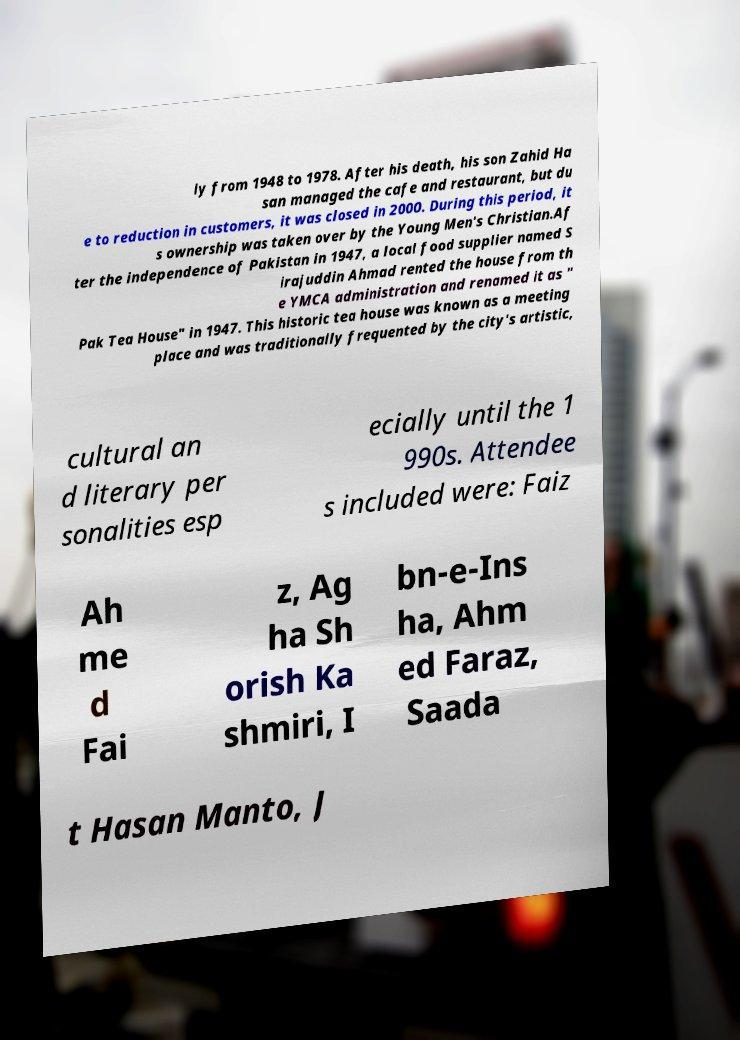Please identify and transcribe the text found in this image. ly from 1948 to 1978. After his death, his son Zahid Ha san managed the cafe and restaurant, but du e to reduction in customers, it was closed in 2000. During this period, it s ownership was taken over by the Young Men's Christian.Af ter the independence of Pakistan in 1947, a local food supplier named S irajuddin Ahmad rented the house from th e YMCA administration and renamed it as " Pak Tea House" in 1947. This historic tea house was known as a meeting place and was traditionally frequented by the city's artistic, cultural an d literary per sonalities esp ecially until the 1 990s. Attendee s included were: Faiz Ah me d Fai z, Ag ha Sh orish Ka shmiri, I bn-e-Ins ha, Ahm ed Faraz, Saada t Hasan Manto, J 